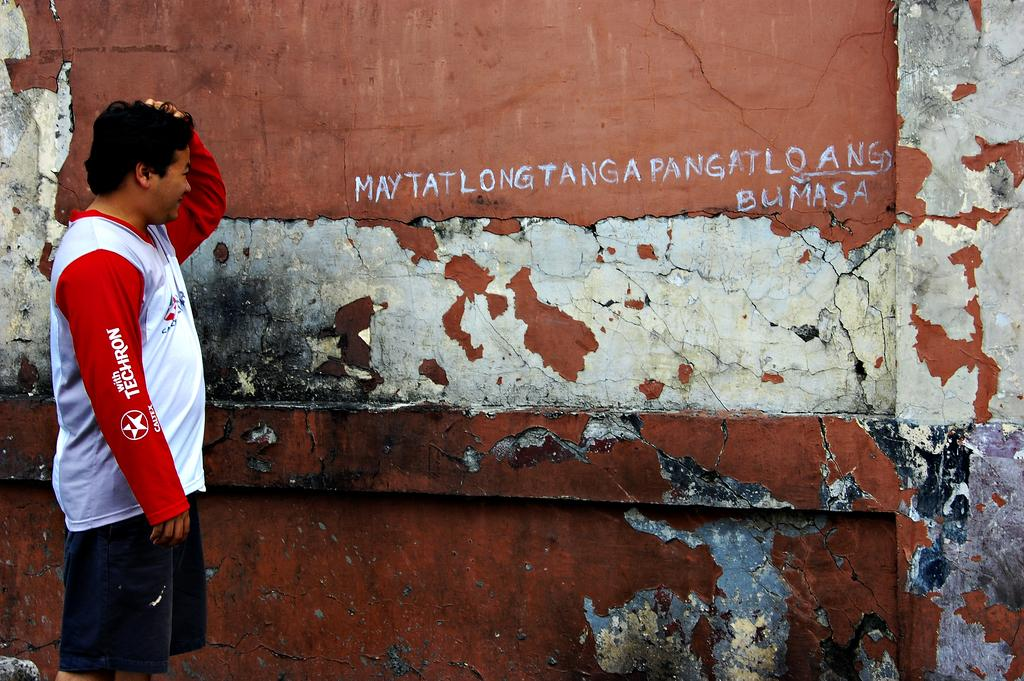<image>
Render a clear and concise summary of the photo. A young man wears a t-shirt with Techron on the sleeve. 